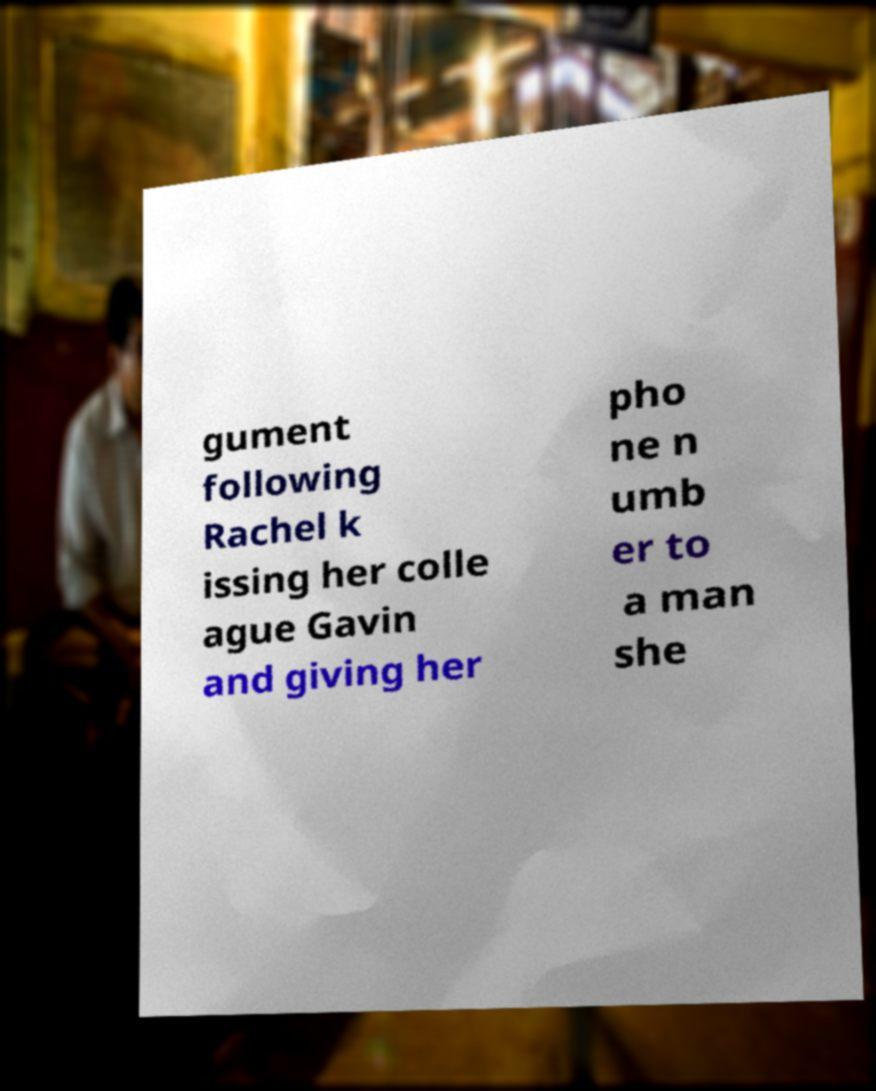I need the written content from this picture converted into text. Can you do that? gument following Rachel k issing her colle ague Gavin and giving her pho ne n umb er to a man she 